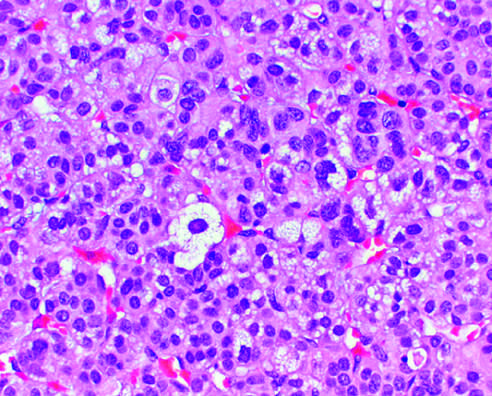s separate mild nuclear pleomorphism?
Answer the question using a single word or phrase. No 